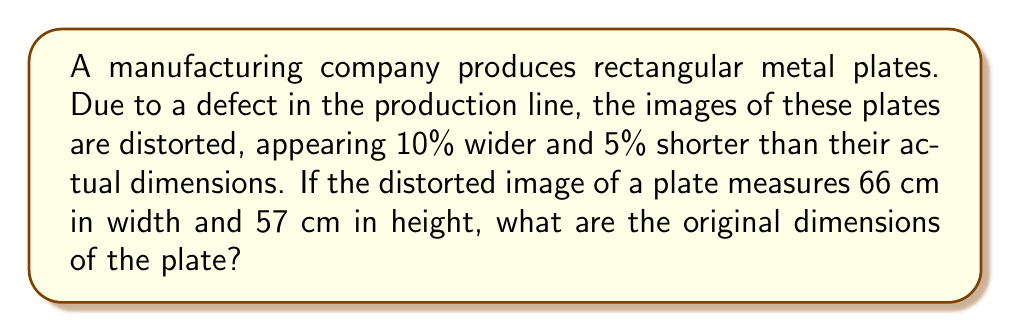Teach me how to tackle this problem. Let's approach this step-by-step:

1) Let the original width be $w$ cm and the original height be $h$ cm.

2) The distorted width is 10% larger than the original:
   $$w \times 1.10 = 66$$

3) The distorted height is 5% smaller than the original:
   $$h \times 0.95 = 57$$

4) To find the original width:
   $$w = \frac{66}{1.10} = 60$$

5) To find the original height:
   $$h = \frac{57}{0.95} = 60$$

6) Therefore, the original dimensions are 60 cm × 60 cm.

This problem demonstrates how manufacturing defects can distort product measurements, a common issue in quality control. As a senior executive, understanding how to reverse-engineer such distortions is crucial for maintaining product quality and addressing production line issues.
Answer: 60 cm × 60 cm 